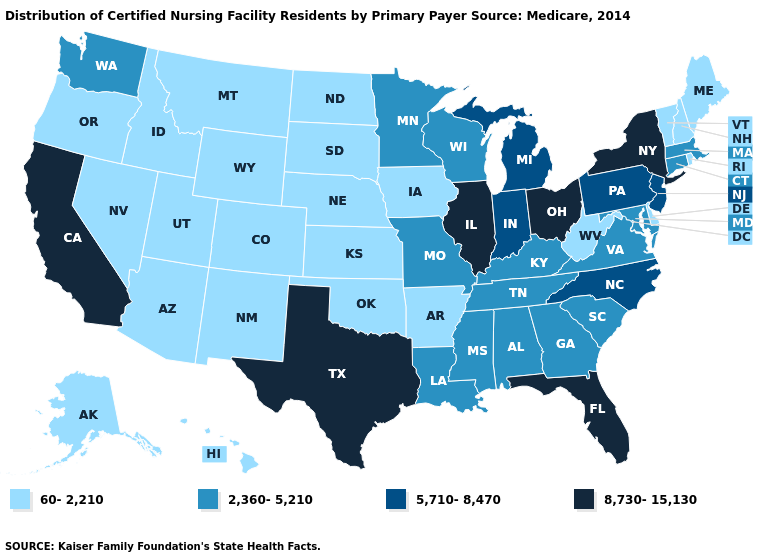What is the lowest value in the USA?
Give a very brief answer. 60-2,210. Which states have the lowest value in the MidWest?
Concise answer only. Iowa, Kansas, Nebraska, North Dakota, South Dakota. What is the highest value in the USA?
Quick response, please. 8,730-15,130. Name the states that have a value in the range 60-2,210?
Short answer required. Alaska, Arizona, Arkansas, Colorado, Delaware, Hawaii, Idaho, Iowa, Kansas, Maine, Montana, Nebraska, Nevada, New Hampshire, New Mexico, North Dakota, Oklahoma, Oregon, Rhode Island, South Dakota, Utah, Vermont, West Virginia, Wyoming. What is the value of Washington?
Quick response, please. 2,360-5,210. Among the states that border Wyoming , which have the highest value?
Answer briefly. Colorado, Idaho, Montana, Nebraska, South Dakota, Utah. Does Texas have the lowest value in the USA?
Short answer required. No. Which states have the highest value in the USA?
Quick response, please. California, Florida, Illinois, New York, Ohio, Texas. Which states hav the highest value in the West?
Write a very short answer. California. Among the states that border Arizona , does Colorado have the lowest value?
Be succinct. Yes. What is the lowest value in the MidWest?
Quick response, please. 60-2,210. What is the value of North Carolina?
Give a very brief answer. 5,710-8,470. What is the value of South Carolina?
Short answer required. 2,360-5,210. Which states have the lowest value in the USA?
Answer briefly. Alaska, Arizona, Arkansas, Colorado, Delaware, Hawaii, Idaho, Iowa, Kansas, Maine, Montana, Nebraska, Nevada, New Hampshire, New Mexico, North Dakota, Oklahoma, Oregon, Rhode Island, South Dakota, Utah, Vermont, West Virginia, Wyoming. What is the highest value in the West ?
Write a very short answer. 8,730-15,130. 